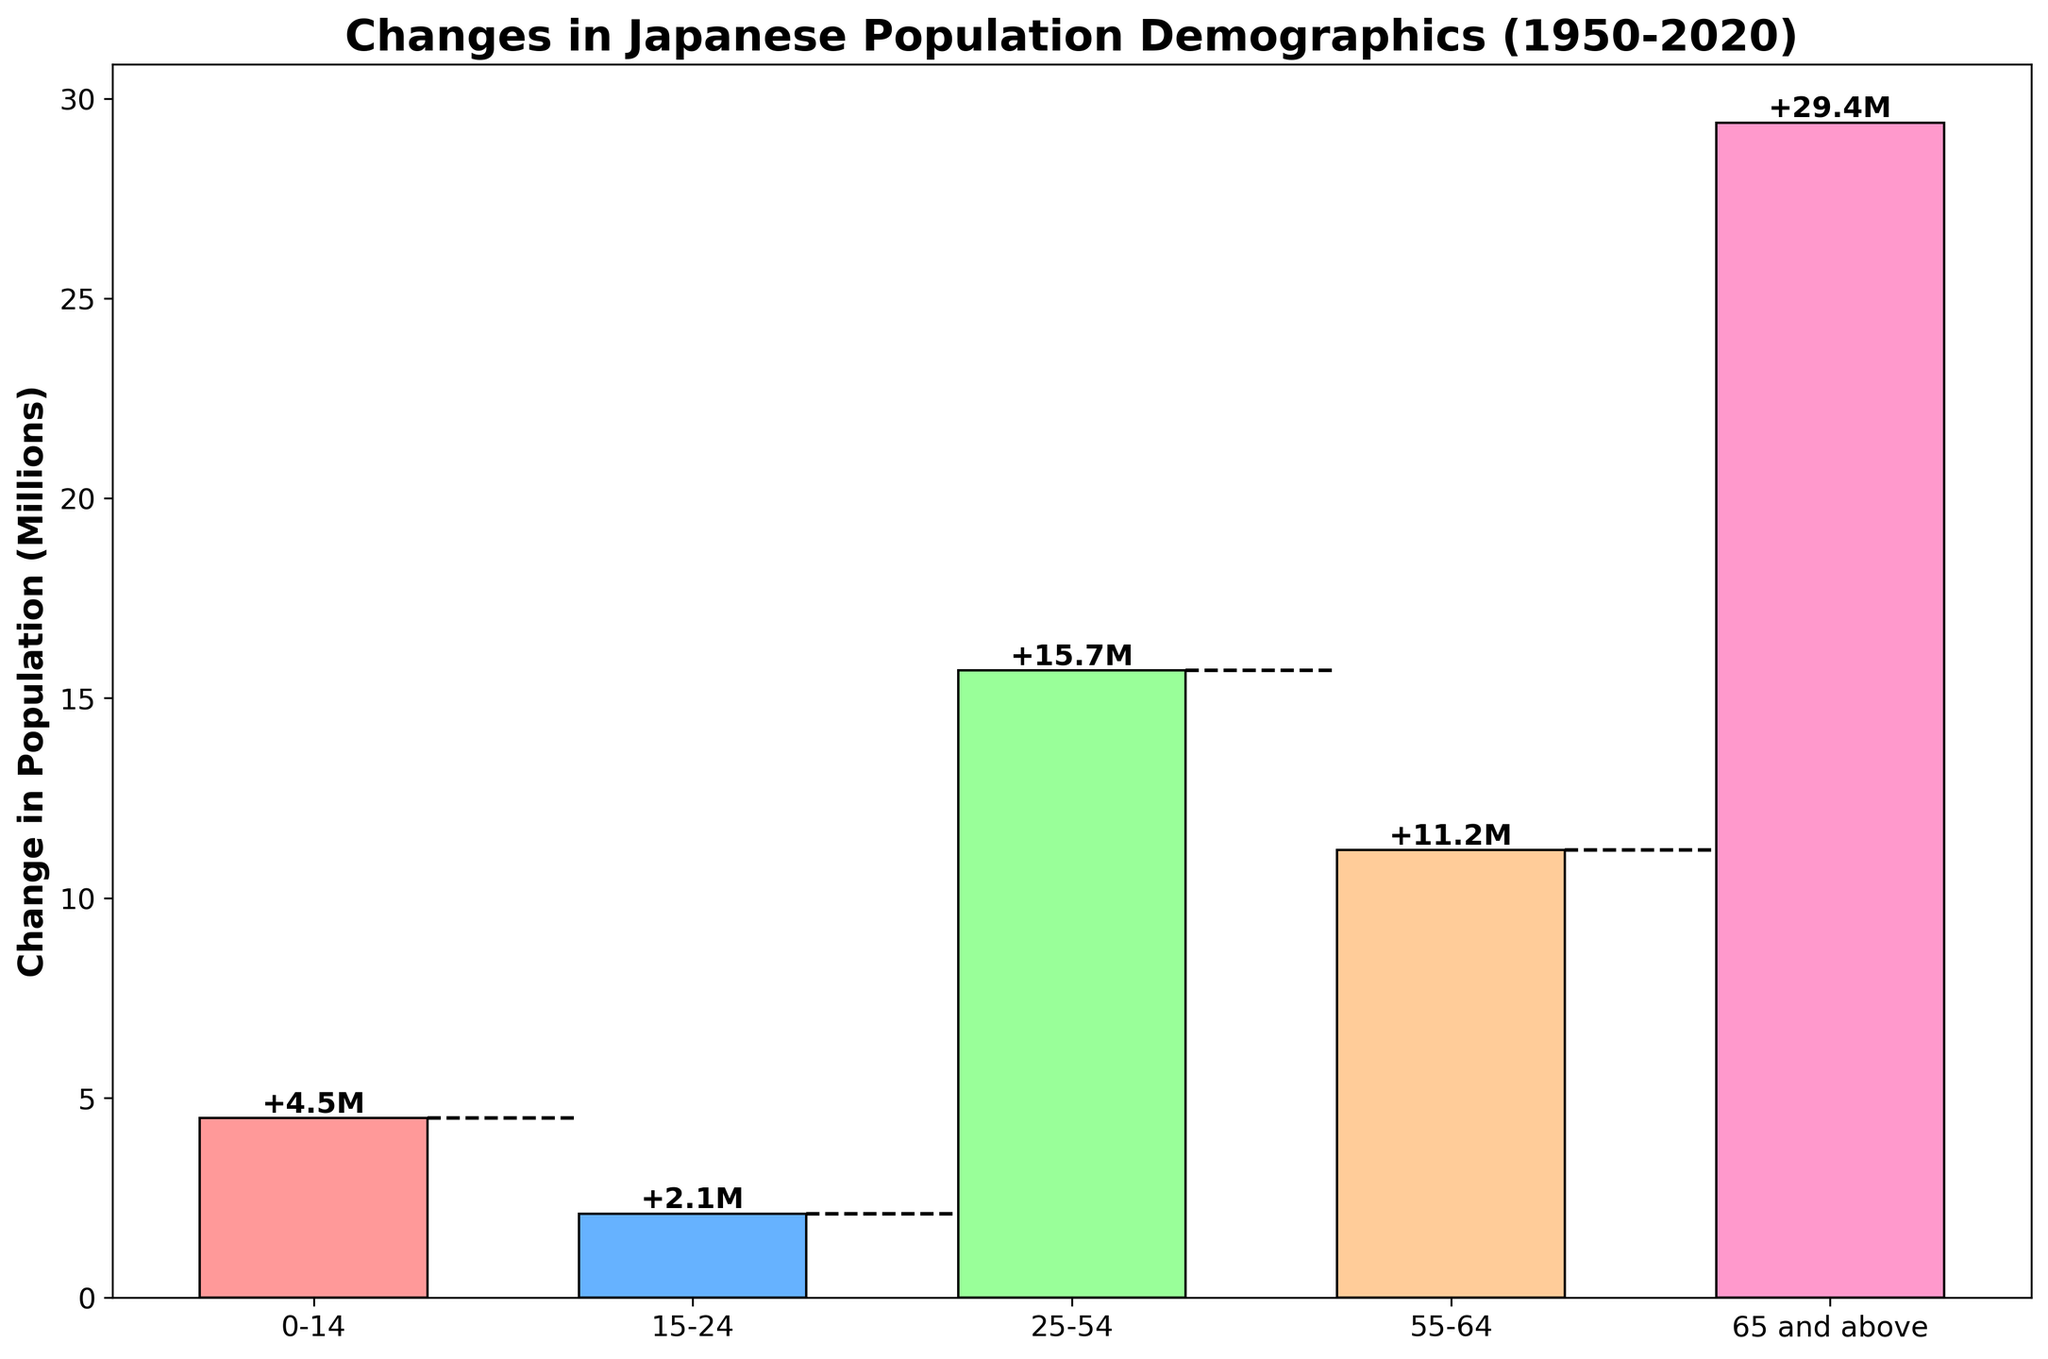what is the title of the plot? The title of the plot is usually displayed prominently at the top of the figure. Here, the title can be directly read from the top of the chart.
Answer: Changes in Japanese Population Demographics (1950-2020) How many age groups are shown in the plot? The number of age groups can be counted from the distinct bars shown in the waterfall chart.
Answer: 5 Which age group had the highest change in population? To determine the highest change in population, locate the tallest bar in the chart. The 65 and above age group has the largest bar.
Answer: 65 and above What is the population change for the 15-24 age group? Find the bar labeled 15-24 and read the value from the label or height of the bar.
Answer: +2.1 million Which age group had the smallest change in population? Compare the heights of all the bars to find the shortest one. The 15-24 age group has the smallest bar.
Answer: 15-24 What total population change does the plot indicate? The total change is often noted but can also be calculated by summing up the values of all bars. The figure shows +62.9 million as the total change.
Answer: +62.9 million How does the change in population for the age group 0-14 compare to 55-64? Compare the heights of the bars for the 0-14 and 55-64 age groups to see which is taller. The 55-64 group had a larger change.
Answer: 55-64 By how much did the 65 and above age group increase? Identify the bar for the 65 and above age group and read the population change value.
Answer: +29.4 million What are the colors used for the different age groups in the plot? Observe the color of each bar representing an age group. The first bar is red, the second is blue, the third is green, the fourth is orange, and the fifth is pink.
Answer: Red, blue, green, orange, pink 